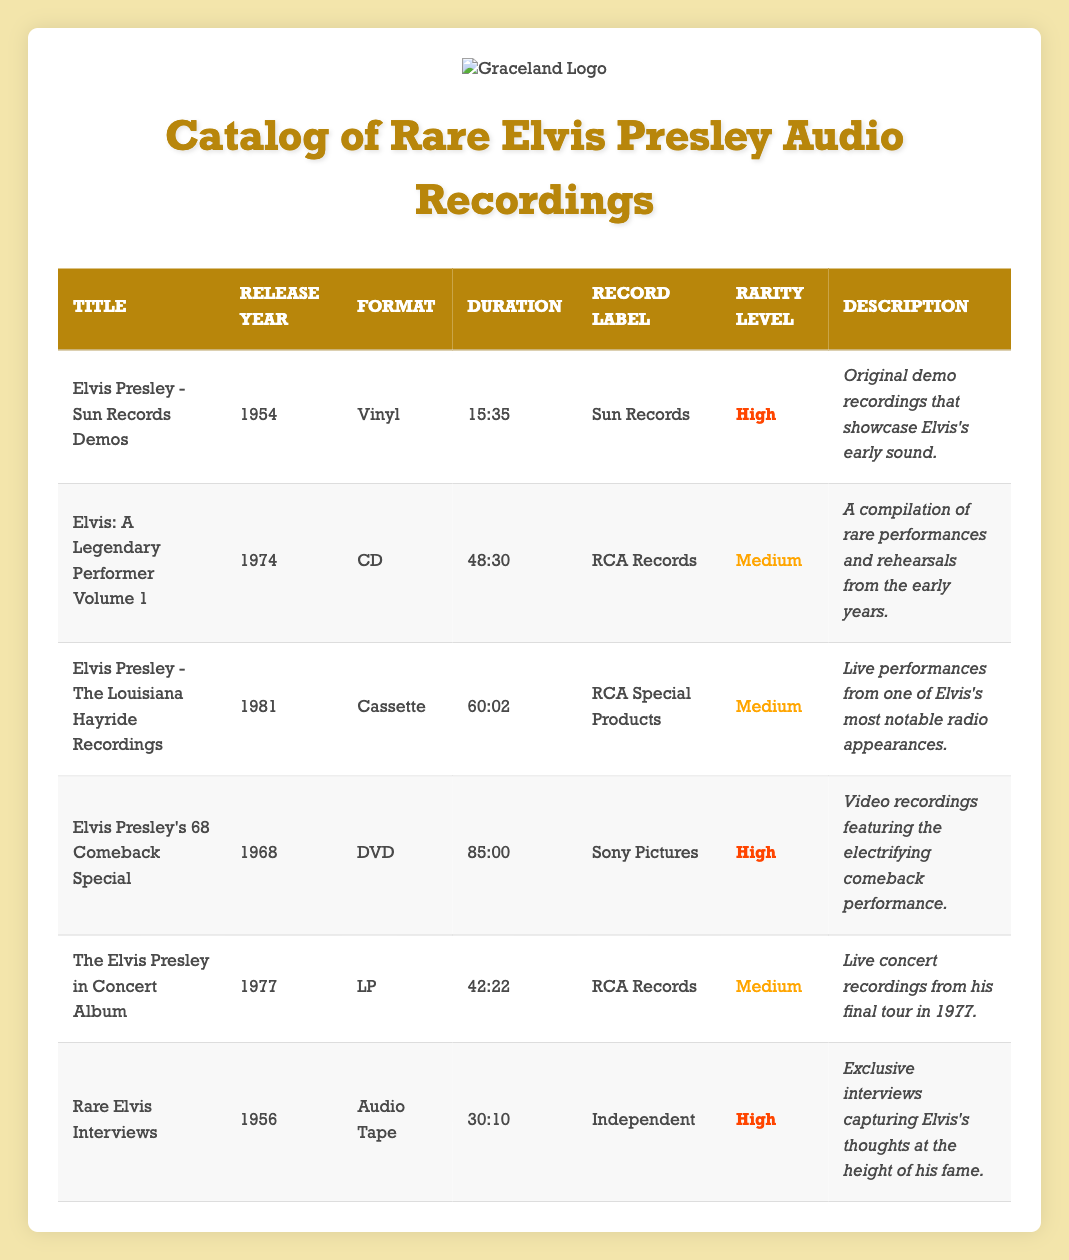What is the total duration of all audio recordings listed? To find the total duration, we need to convert each duration into minutes and seconds, sum them up, and convert the result back. The durations are: 15:35, 48:30, 60:02, 85:00, 42:22, and 30:10. Converting them to total seconds: 935 + 2910 + 3602 + 5100 + 2542 + 1810 = 13289 seconds. Then, we convert this back to minutes and seconds: 13289 seconds = 221 minutes and 29 seconds.
Answer: 221:29 Which audio recording has the highest rarity level? Looking at the rarity levels in the table, "Elvis Presley - Sun Records Demos", "Elvis Presley's 68 Comeback Special", and "Rare Elvis Interviews" are labeled as high rarity. The first one in the list is "Elvis Presley - Sun Records Demos".
Answer: Elvis Presley - Sun Records Demos What percentage of the recordings are in vinyl format? There are a total of 6 audio recordings listed. Only 1 of them is in vinyl format: "Elvis Presley - Sun Records Demos". To find the percentage: (1/6) * 100 = 16.67%.
Answer: 16.67% Is there any recording released in 1974? By scanning the release years, we can see that "Elvis: A Legendary Performer Volume 1" has been released in 1974.
Answer: Yes How many recordings have a duration longer than 60 minutes? We review the durations: "Elvis Presley - The Louisiana Hayride Recordings" (60:02) and "Elvis Presley's 68 Comeback Special" (85:00) are the only ones longer than 60 minutes. Thus, there are two recordings longer than 60 minutes.
Answer: 2 What is the most recent release year in the catalog? The release years in the table are: 1954, 1974, 1981, 1968, 1977, and 1956. The most recent year among these is 1981, which corresponds to "Elvis Presley - The Louisiana Hayride Recordings".
Answer: 1981 How many different formats are represented in the recordings? The formats presented are: Vinyl, CD, Cassette, DVD, and LP. Counting these, we have a total of 5 unique formats.
Answer: 5 Is there a recording from the 1950s in the catalog? Both "Elvis Presley - Sun Records Demos" (1954) and "Rare Elvis Interviews" (1956) are from the 1950s, as indicated by their release years.
Answer: Yes 